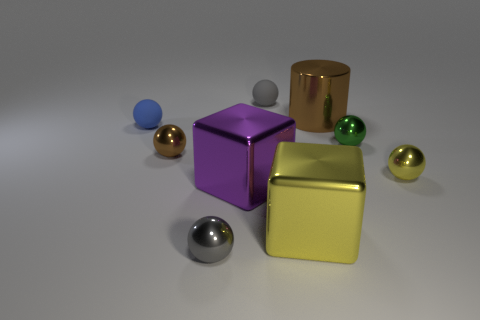Can you tell me which objects in the image are reflective? Certainly, the objects that exhibit reflectiveness in the image include the purple, gold, and silver blocks, along with the smaller spherical objects that appear to be made of materials like polished metal or glass. How would lighting affect the appearance of these objects? Lighting plays a crucial role in the appearance of reflective objects. Bright, direct light would enhance the reflectiveness, creating strong highlights and defined shadows, while diffused lighting would soften the reflections and shadows, giving a more even and muted appearance to the objects. 